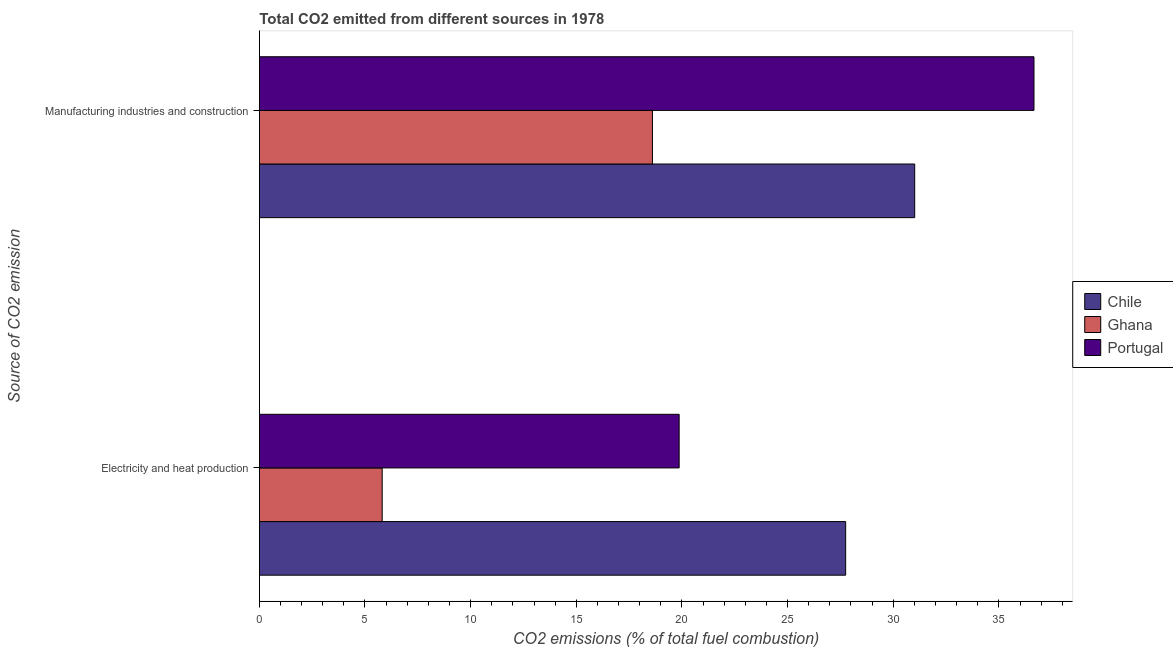How many different coloured bars are there?
Offer a very short reply. 3. How many groups of bars are there?
Your answer should be very brief. 2. Are the number of bars per tick equal to the number of legend labels?
Keep it short and to the point. Yes. Are the number of bars on each tick of the Y-axis equal?
Your answer should be very brief. Yes. How many bars are there on the 1st tick from the top?
Offer a terse response. 3. What is the label of the 2nd group of bars from the top?
Offer a terse response. Electricity and heat production. What is the co2 emissions due to manufacturing industries in Portugal?
Your answer should be compact. 36.66. Across all countries, what is the maximum co2 emissions due to electricity and heat production?
Offer a terse response. 27.75. Across all countries, what is the minimum co2 emissions due to manufacturing industries?
Provide a succinct answer. 18.6. What is the total co2 emissions due to manufacturing industries in the graph?
Keep it short and to the point. 86.28. What is the difference between the co2 emissions due to electricity and heat production in Portugal and that in Chile?
Make the answer very short. -7.88. What is the difference between the co2 emissions due to manufacturing industries in Ghana and the co2 emissions due to electricity and heat production in Portugal?
Ensure brevity in your answer.  -1.26. What is the average co2 emissions due to electricity and heat production per country?
Keep it short and to the point. 17.81. What is the difference between the co2 emissions due to electricity and heat production and co2 emissions due to manufacturing industries in Ghana?
Offer a terse response. -12.79. What is the ratio of the co2 emissions due to electricity and heat production in Portugal to that in Ghana?
Give a very brief answer. 3.42. Is the co2 emissions due to electricity and heat production in Ghana less than that in Portugal?
Your answer should be compact. Yes. In how many countries, is the co2 emissions due to electricity and heat production greater than the average co2 emissions due to electricity and heat production taken over all countries?
Your answer should be compact. 2. What does the 3rd bar from the top in Manufacturing industries and construction represents?
Your response must be concise. Chile. How many bars are there?
Your response must be concise. 6. Are all the bars in the graph horizontal?
Your answer should be compact. Yes. What is the difference between two consecutive major ticks on the X-axis?
Give a very brief answer. 5. Does the graph contain grids?
Your answer should be very brief. No. How are the legend labels stacked?
Offer a very short reply. Vertical. What is the title of the graph?
Your answer should be very brief. Total CO2 emitted from different sources in 1978. What is the label or title of the X-axis?
Offer a terse response. CO2 emissions (% of total fuel combustion). What is the label or title of the Y-axis?
Provide a short and direct response. Source of CO2 emission. What is the CO2 emissions (% of total fuel combustion) in Chile in Electricity and heat production?
Ensure brevity in your answer.  27.75. What is the CO2 emissions (% of total fuel combustion) of Ghana in Electricity and heat production?
Ensure brevity in your answer.  5.81. What is the CO2 emissions (% of total fuel combustion) of Portugal in Electricity and heat production?
Your response must be concise. 19.87. What is the CO2 emissions (% of total fuel combustion) of Chile in Manufacturing industries and construction?
Your response must be concise. 31.02. What is the CO2 emissions (% of total fuel combustion) in Ghana in Manufacturing industries and construction?
Keep it short and to the point. 18.6. What is the CO2 emissions (% of total fuel combustion) of Portugal in Manufacturing industries and construction?
Make the answer very short. 36.66. Across all Source of CO2 emission, what is the maximum CO2 emissions (% of total fuel combustion) in Chile?
Offer a terse response. 31.02. Across all Source of CO2 emission, what is the maximum CO2 emissions (% of total fuel combustion) in Ghana?
Your answer should be compact. 18.6. Across all Source of CO2 emission, what is the maximum CO2 emissions (% of total fuel combustion) in Portugal?
Keep it short and to the point. 36.66. Across all Source of CO2 emission, what is the minimum CO2 emissions (% of total fuel combustion) of Chile?
Provide a succinct answer. 27.75. Across all Source of CO2 emission, what is the minimum CO2 emissions (% of total fuel combustion) of Ghana?
Offer a terse response. 5.81. Across all Source of CO2 emission, what is the minimum CO2 emissions (% of total fuel combustion) in Portugal?
Make the answer very short. 19.87. What is the total CO2 emissions (% of total fuel combustion) of Chile in the graph?
Ensure brevity in your answer.  58.77. What is the total CO2 emissions (% of total fuel combustion) of Ghana in the graph?
Make the answer very short. 24.42. What is the total CO2 emissions (% of total fuel combustion) in Portugal in the graph?
Make the answer very short. 56.53. What is the difference between the CO2 emissions (% of total fuel combustion) of Chile in Electricity and heat production and that in Manufacturing industries and construction?
Provide a short and direct response. -3.27. What is the difference between the CO2 emissions (% of total fuel combustion) in Ghana in Electricity and heat production and that in Manufacturing industries and construction?
Your answer should be compact. -12.79. What is the difference between the CO2 emissions (% of total fuel combustion) of Portugal in Electricity and heat production and that in Manufacturing industries and construction?
Your answer should be very brief. -16.79. What is the difference between the CO2 emissions (% of total fuel combustion) in Chile in Electricity and heat production and the CO2 emissions (% of total fuel combustion) in Ghana in Manufacturing industries and construction?
Make the answer very short. 9.14. What is the difference between the CO2 emissions (% of total fuel combustion) of Chile in Electricity and heat production and the CO2 emissions (% of total fuel combustion) of Portugal in Manufacturing industries and construction?
Give a very brief answer. -8.91. What is the difference between the CO2 emissions (% of total fuel combustion) in Ghana in Electricity and heat production and the CO2 emissions (% of total fuel combustion) in Portugal in Manufacturing industries and construction?
Offer a terse response. -30.85. What is the average CO2 emissions (% of total fuel combustion) in Chile per Source of CO2 emission?
Provide a short and direct response. 29.38. What is the average CO2 emissions (% of total fuel combustion) of Ghana per Source of CO2 emission?
Give a very brief answer. 12.21. What is the average CO2 emissions (% of total fuel combustion) in Portugal per Source of CO2 emission?
Ensure brevity in your answer.  28.27. What is the difference between the CO2 emissions (% of total fuel combustion) of Chile and CO2 emissions (% of total fuel combustion) of Ghana in Electricity and heat production?
Your response must be concise. 21.93. What is the difference between the CO2 emissions (% of total fuel combustion) of Chile and CO2 emissions (% of total fuel combustion) of Portugal in Electricity and heat production?
Offer a very short reply. 7.88. What is the difference between the CO2 emissions (% of total fuel combustion) in Ghana and CO2 emissions (% of total fuel combustion) in Portugal in Electricity and heat production?
Keep it short and to the point. -14.05. What is the difference between the CO2 emissions (% of total fuel combustion) in Chile and CO2 emissions (% of total fuel combustion) in Ghana in Manufacturing industries and construction?
Ensure brevity in your answer.  12.41. What is the difference between the CO2 emissions (% of total fuel combustion) of Chile and CO2 emissions (% of total fuel combustion) of Portugal in Manufacturing industries and construction?
Your response must be concise. -5.64. What is the difference between the CO2 emissions (% of total fuel combustion) in Ghana and CO2 emissions (% of total fuel combustion) in Portugal in Manufacturing industries and construction?
Offer a terse response. -18.06. What is the ratio of the CO2 emissions (% of total fuel combustion) in Chile in Electricity and heat production to that in Manufacturing industries and construction?
Offer a terse response. 0.89. What is the ratio of the CO2 emissions (% of total fuel combustion) of Ghana in Electricity and heat production to that in Manufacturing industries and construction?
Give a very brief answer. 0.31. What is the ratio of the CO2 emissions (% of total fuel combustion) in Portugal in Electricity and heat production to that in Manufacturing industries and construction?
Keep it short and to the point. 0.54. What is the difference between the highest and the second highest CO2 emissions (% of total fuel combustion) of Chile?
Offer a terse response. 3.27. What is the difference between the highest and the second highest CO2 emissions (% of total fuel combustion) in Ghana?
Provide a succinct answer. 12.79. What is the difference between the highest and the second highest CO2 emissions (% of total fuel combustion) in Portugal?
Make the answer very short. 16.79. What is the difference between the highest and the lowest CO2 emissions (% of total fuel combustion) of Chile?
Your response must be concise. 3.27. What is the difference between the highest and the lowest CO2 emissions (% of total fuel combustion) of Ghana?
Your answer should be very brief. 12.79. What is the difference between the highest and the lowest CO2 emissions (% of total fuel combustion) of Portugal?
Give a very brief answer. 16.79. 